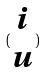Convert formula to latex. <formula><loc_0><loc_0><loc_500><loc_500>( \begin{matrix} i \\ u \end{matrix} )</formula> 